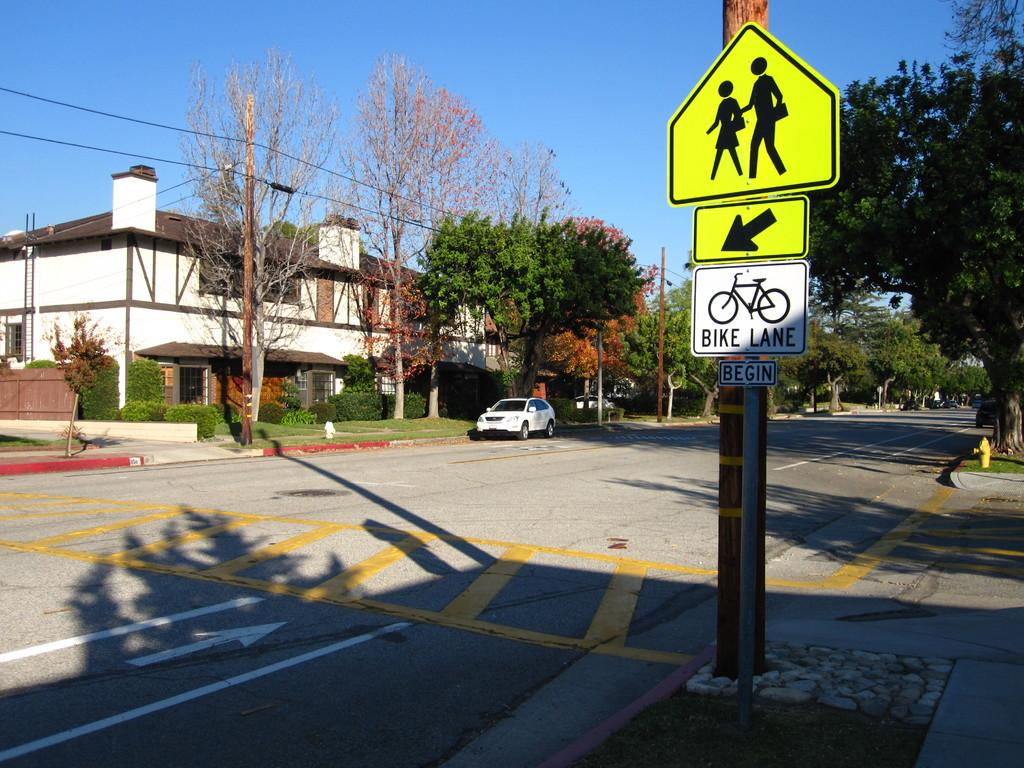<image>
Provide a brief description of the given image. A street sign below the crosswalk sign indicates that the bike lane is beginning. 